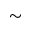<formula> <loc_0><loc_0><loc_500><loc_500>\sim</formula> 